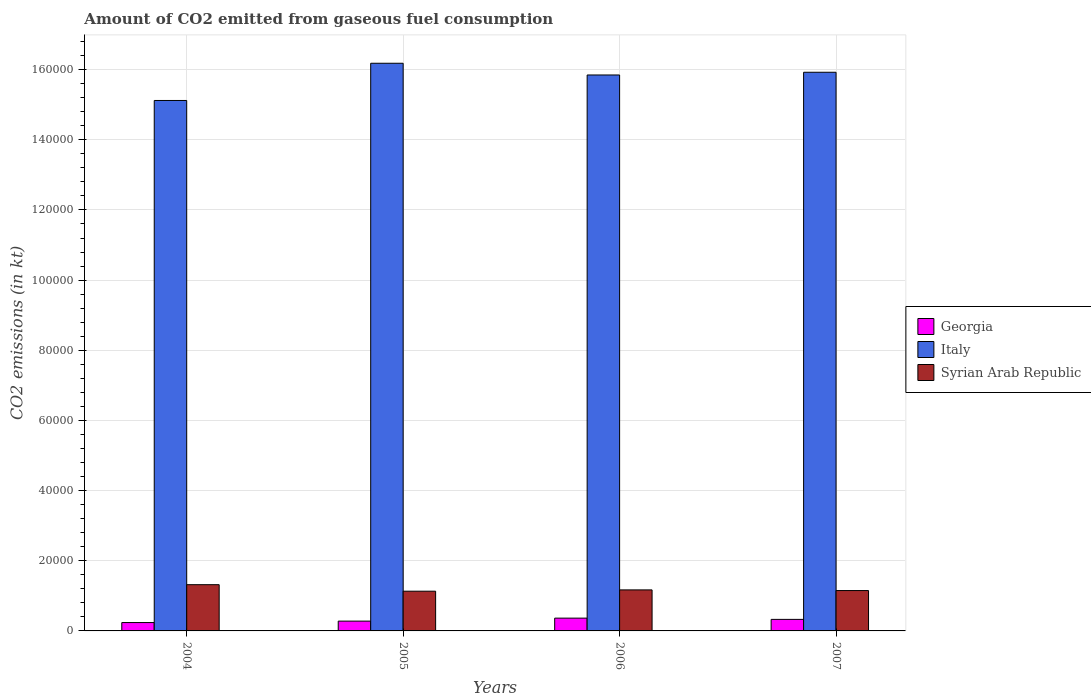How many groups of bars are there?
Make the answer very short. 4. Are the number of bars on each tick of the X-axis equal?
Provide a short and direct response. Yes. How many bars are there on the 2nd tick from the left?
Provide a short and direct response. 3. In how many cases, is the number of bars for a given year not equal to the number of legend labels?
Offer a very short reply. 0. What is the amount of CO2 emitted in Italy in 2006?
Provide a succinct answer. 1.58e+05. Across all years, what is the maximum amount of CO2 emitted in Italy?
Provide a short and direct response. 1.62e+05. Across all years, what is the minimum amount of CO2 emitted in Syrian Arab Republic?
Provide a succinct answer. 1.13e+04. In which year was the amount of CO2 emitted in Italy maximum?
Your answer should be very brief. 2005. What is the total amount of CO2 emitted in Italy in the graph?
Offer a terse response. 6.31e+05. What is the difference between the amount of CO2 emitted in Syrian Arab Republic in 2004 and that in 2006?
Make the answer very short. 1485.14. What is the difference between the amount of CO2 emitted in Syrian Arab Republic in 2007 and the amount of CO2 emitted in Italy in 2006?
Ensure brevity in your answer.  -1.47e+05. What is the average amount of CO2 emitted in Georgia per year?
Provide a succinct answer. 3028.03. In the year 2005, what is the difference between the amount of CO2 emitted in Georgia and amount of CO2 emitted in Syrian Arab Republic?
Provide a short and direct response. -8529.44. What is the ratio of the amount of CO2 emitted in Italy in 2004 to that in 2005?
Provide a short and direct response. 0.93. What is the difference between the highest and the second highest amount of CO2 emitted in Italy?
Your answer should be very brief. 2566.9. What is the difference between the highest and the lowest amount of CO2 emitted in Georgia?
Provide a short and direct response. 1261.45. In how many years, is the amount of CO2 emitted in Syrian Arab Republic greater than the average amount of CO2 emitted in Syrian Arab Republic taken over all years?
Provide a succinct answer. 1. Is the sum of the amount of CO2 emitted in Georgia in 2005 and 2006 greater than the maximum amount of CO2 emitted in Italy across all years?
Keep it short and to the point. No. Are all the bars in the graph horizontal?
Give a very brief answer. No. How many years are there in the graph?
Your answer should be compact. 4. What is the difference between two consecutive major ticks on the Y-axis?
Offer a very short reply. 2.00e+04. Does the graph contain any zero values?
Your answer should be compact. No. Does the graph contain grids?
Your answer should be very brief. Yes. Where does the legend appear in the graph?
Provide a short and direct response. Center right. What is the title of the graph?
Your answer should be very brief. Amount of CO2 emitted from gaseous fuel consumption. Does "American Samoa" appear as one of the legend labels in the graph?
Your answer should be compact. No. What is the label or title of the X-axis?
Provide a succinct answer. Years. What is the label or title of the Y-axis?
Offer a terse response. CO2 emissions (in kt). What is the CO2 emissions (in kt) in Georgia in 2004?
Provide a short and direct response. 2383.55. What is the CO2 emissions (in kt) in Italy in 2004?
Your answer should be very brief. 1.51e+05. What is the CO2 emissions (in kt) in Syrian Arab Republic in 2004?
Give a very brief answer. 1.32e+04. What is the CO2 emissions (in kt) of Georgia in 2005?
Provide a succinct answer. 2794.25. What is the CO2 emissions (in kt) of Italy in 2005?
Give a very brief answer. 1.62e+05. What is the CO2 emissions (in kt) in Syrian Arab Republic in 2005?
Keep it short and to the point. 1.13e+04. What is the CO2 emissions (in kt) in Georgia in 2006?
Offer a very short reply. 3645. What is the CO2 emissions (in kt) in Italy in 2006?
Provide a succinct answer. 1.58e+05. What is the CO2 emissions (in kt) of Syrian Arab Republic in 2006?
Give a very brief answer. 1.17e+04. What is the CO2 emissions (in kt) of Georgia in 2007?
Your answer should be compact. 3289.3. What is the CO2 emissions (in kt) of Italy in 2007?
Make the answer very short. 1.59e+05. What is the CO2 emissions (in kt) in Syrian Arab Republic in 2007?
Your answer should be compact. 1.15e+04. Across all years, what is the maximum CO2 emissions (in kt) of Georgia?
Ensure brevity in your answer.  3645. Across all years, what is the maximum CO2 emissions (in kt) of Italy?
Your answer should be very brief. 1.62e+05. Across all years, what is the maximum CO2 emissions (in kt) of Syrian Arab Republic?
Your answer should be very brief. 1.32e+04. Across all years, what is the minimum CO2 emissions (in kt) of Georgia?
Keep it short and to the point. 2383.55. Across all years, what is the minimum CO2 emissions (in kt) in Italy?
Make the answer very short. 1.51e+05. Across all years, what is the minimum CO2 emissions (in kt) in Syrian Arab Republic?
Your answer should be compact. 1.13e+04. What is the total CO2 emissions (in kt) of Georgia in the graph?
Offer a very short reply. 1.21e+04. What is the total CO2 emissions (in kt) of Italy in the graph?
Your answer should be very brief. 6.31e+05. What is the total CO2 emissions (in kt) of Syrian Arab Republic in the graph?
Offer a terse response. 4.77e+04. What is the difference between the CO2 emissions (in kt) of Georgia in 2004 and that in 2005?
Make the answer very short. -410.7. What is the difference between the CO2 emissions (in kt) of Italy in 2004 and that in 2005?
Make the answer very short. -1.06e+04. What is the difference between the CO2 emissions (in kt) of Syrian Arab Republic in 2004 and that in 2005?
Make the answer very short. 1855.5. What is the difference between the CO2 emissions (in kt) in Georgia in 2004 and that in 2006?
Your answer should be compact. -1261.45. What is the difference between the CO2 emissions (in kt) of Italy in 2004 and that in 2006?
Offer a terse response. -7267.99. What is the difference between the CO2 emissions (in kt) of Syrian Arab Republic in 2004 and that in 2006?
Keep it short and to the point. 1485.13. What is the difference between the CO2 emissions (in kt) in Georgia in 2004 and that in 2007?
Provide a succinct answer. -905.75. What is the difference between the CO2 emissions (in kt) of Italy in 2004 and that in 2007?
Your answer should be very brief. -8041.73. What is the difference between the CO2 emissions (in kt) of Syrian Arab Republic in 2004 and that in 2007?
Make the answer very short. 1672.15. What is the difference between the CO2 emissions (in kt) in Georgia in 2005 and that in 2006?
Your answer should be very brief. -850.74. What is the difference between the CO2 emissions (in kt) in Italy in 2005 and that in 2006?
Your response must be concise. 3340.64. What is the difference between the CO2 emissions (in kt) of Syrian Arab Republic in 2005 and that in 2006?
Ensure brevity in your answer.  -370.37. What is the difference between the CO2 emissions (in kt) in Georgia in 2005 and that in 2007?
Your response must be concise. -495.05. What is the difference between the CO2 emissions (in kt) of Italy in 2005 and that in 2007?
Your answer should be compact. 2566.9. What is the difference between the CO2 emissions (in kt) of Syrian Arab Republic in 2005 and that in 2007?
Offer a very short reply. -183.35. What is the difference between the CO2 emissions (in kt) of Georgia in 2006 and that in 2007?
Make the answer very short. 355.7. What is the difference between the CO2 emissions (in kt) of Italy in 2006 and that in 2007?
Make the answer very short. -773.74. What is the difference between the CO2 emissions (in kt) of Syrian Arab Republic in 2006 and that in 2007?
Ensure brevity in your answer.  187.02. What is the difference between the CO2 emissions (in kt) of Georgia in 2004 and the CO2 emissions (in kt) of Italy in 2005?
Your response must be concise. -1.59e+05. What is the difference between the CO2 emissions (in kt) of Georgia in 2004 and the CO2 emissions (in kt) of Syrian Arab Republic in 2005?
Make the answer very short. -8940.15. What is the difference between the CO2 emissions (in kt) in Italy in 2004 and the CO2 emissions (in kt) in Syrian Arab Republic in 2005?
Offer a very short reply. 1.40e+05. What is the difference between the CO2 emissions (in kt) of Georgia in 2004 and the CO2 emissions (in kt) of Italy in 2006?
Make the answer very short. -1.56e+05. What is the difference between the CO2 emissions (in kt) of Georgia in 2004 and the CO2 emissions (in kt) of Syrian Arab Republic in 2006?
Your answer should be very brief. -9310.51. What is the difference between the CO2 emissions (in kt) in Italy in 2004 and the CO2 emissions (in kt) in Syrian Arab Republic in 2006?
Offer a very short reply. 1.40e+05. What is the difference between the CO2 emissions (in kt) of Georgia in 2004 and the CO2 emissions (in kt) of Italy in 2007?
Ensure brevity in your answer.  -1.57e+05. What is the difference between the CO2 emissions (in kt) of Georgia in 2004 and the CO2 emissions (in kt) of Syrian Arab Republic in 2007?
Offer a very short reply. -9123.5. What is the difference between the CO2 emissions (in kt) in Italy in 2004 and the CO2 emissions (in kt) in Syrian Arab Republic in 2007?
Offer a very short reply. 1.40e+05. What is the difference between the CO2 emissions (in kt) in Georgia in 2005 and the CO2 emissions (in kt) in Italy in 2006?
Offer a terse response. -1.56e+05. What is the difference between the CO2 emissions (in kt) in Georgia in 2005 and the CO2 emissions (in kt) in Syrian Arab Republic in 2006?
Offer a very short reply. -8899.81. What is the difference between the CO2 emissions (in kt) of Italy in 2005 and the CO2 emissions (in kt) of Syrian Arab Republic in 2006?
Your answer should be compact. 1.50e+05. What is the difference between the CO2 emissions (in kt) in Georgia in 2005 and the CO2 emissions (in kt) in Italy in 2007?
Provide a succinct answer. -1.56e+05. What is the difference between the CO2 emissions (in kt) of Georgia in 2005 and the CO2 emissions (in kt) of Syrian Arab Republic in 2007?
Your answer should be compact. -8712.79. What is the difference between the CO2 emissions (in kt) of Italy in 2005 and the CO2 emissions (in kt) of Syrian Arab Republic in 2007?
Keep it short and to the point. 1.50e+05. What is the difference between the CO2 emissions (in kt) in Georgia in 2006 and the CO2 emissions (in kt) in Italy in 2007?
Give a very brief answer. -1.56e+05. What is the difference between the CO2 emissions (in kt) in Georgia in 2006 and the CO2 emissions (in kt) in Syrian Arab Republic in 2007?
Give a very brief answer. -7862.05. What is the difference between the CO2 emissions (in kt) of Italy in 2006 and the CO2 emissions (in kt) of Syrian Arab Republic in 2007?
Ensure brevity in your answer.  1.47e+05. What is the average CO2 emissions (in kt) of Georgia per year?
Your response must be concise. 3028.03. What is the average CO2 emissions (in kt) of Italy per year?
Your response must be concise. 1.58e+05. What is the average CO2 emissions (in kt) of Syrian Arab Republic per year?
Your answer should be very brief. 1.19e+04. In the year 2004, what is the difference between the CO2 emissions (in kt) in Georgia and CO2 emissions (in kt) in Italy?
Your response must be concise. -1.49e+05. In the year 2004, what is the difference between the CO2 emissions (in kt) of Georgia and CO2 emissions (in kt) of Syrian Arab Republic?
Make the answer very short. -1.08e+04. In the year 2004, what is the difference between the CO2 emissions (in kt) of Italy and CO2 emissions (in kt) of Syrian Arab Republic?
Ensure brevity in your answer.  1.38e+05. In the year 2005, what is the difference between the CO2 emissions (in kt) of Georgia and CO2 emissions (in kt) of Italy?
Offer a terse response. -1.59e+05. In the year 2005, what is the difference between the CO2 emissions (in kt) in Georgia and CO2 emissions (in kt) in Syrian Arab Republic?
Offer a very short reply. -8529.44. In the year 2005, what is the difference between the CO2 emissions (in kt) of Italy and CO2 emissions (in kt) of Syrian Arab Republic?
Give a very brief answer. 1.50e+05. In the year 2006, what is the difference between the CO2 emissions (in kt) of Georgia and CO2 emissions (in kt) of Italy?
Your answer should be very brief. -1.55e+05. In the year 2006, what is the difference between the CO2 emissions (in kt) of Georgia and CO2 emissions (in kt) of Syrian Arab Republic?
Give a very brief answer. -8049.06. In the year 2006, what is the difference between the CO2 emissions (in kt) of Italy and CO2 emissions (in kt) of Syrian Arab Republic?
Your response must be concise. 1.47e+05. In the year 2007, what is the difference between the CO2 emissions (in kt) in Georgia and CO2 emissions (in kt) in Italy?
Give a very brief answer. -1.56e+05. In the year 2007, what is the difference between the CO2 emissions (in kt) in Georgia and CO2 emissions (in kt) in Syrian Arab Republic?
Offer a very short reply. -8217.75. In the year 2007, what is the difference between the CO2 emissions (in kt) in Italy and CO2 emissions (in kt) in Syrian Arab Republic?
Make the answer very short. 1.48e+05. What is the ratio of the CO2 emissions (in kt) in Georgia in 2004 to that in 2005?
Your response must be concise. 0.85. What is the ratio of the CO2 emissions (in kt) in Italy in 2004 to that in 2005?
Your answer should be compact. 0.93. What is the ratio of the CO2 emissions (in kt) in Syrian Arab Republic in 2004 to that in 2005?
Offer a terse response. 1.16. What is the ratio of the CO2 emissions (in kt) of Georgia in 2004 to that in 2006?
Provide a succinct answer. 0.65. What is the ratio of the CO2 emissions (in kt) of Italy in 2004 to that in 2006?
Offer a very short reply. 0.95. What is the ratio of the CO2 emissions (in kt) of Syrian Arab Republic in 2004 to that in 2006?
Your answer should be compact. 1.13. What is the ratio of the CO2 emissions (in kt) in Georgia in 2004 to that in 2007?
Your answer should be compact. 0.72. What is the ratio of the CO2 emissions (in kt) of Italy in 2004 to that in 2007?
Your answer should be very brief. 0.95. What is the ratio of the CO2 emissions (in kt) of Syrian Arab Republic in 2004 to that in 2007?
Your answer should be compact. 1.15. What is the ratio of the CO2 emissions (in kt) in Georgia in 2005 to that in 2006?
Keep it short and to the point. 0.77. What is the ratio of the CO2 emissions (in kt) in Italy in 2005 to that in 2006?
Your answer should be compact. 1.02. What is the ratio of the CO2 emissions (in kt) in Syrian Arab Republic in 2005 to that in 2006?
Your response must be concise. 0.97. What is the ratio of the CO2 emissions (in kt) in Georgia in 2005 to that in 2007?
Offer a very short reply. 0.85. What is the ratio of the CO2 emissions (in kt) in Italy in 2005 to that in 2007?
Ensure brevity in your answer.  1.02. What is the ratio of the CO2 emissions (in kt) in Syrian Arab Republic in 2005 to that in 2007?
Your answer should be compact. 0.98. What is the ratio of the CO2 emissions (in kt) in Georgia in 2006 to that in 2007?
Your answer should be compact. 1.11. What is the ratio of the CO2 emissions (in kt) in Italy in 2006 to that in 2007?
Ensure brevity in your answer.  1. What is the ratio of the CO2 emissions (in kt) of Syrian Arab Republic in 2006 to that in 2007?
Keep it short and to the point. 1.02. What is the difference between the highest and the second highest CO2 emissions (in kt) in Georgia?
Offer a terse response. 355.7. What is the difference between the highest and the second highest CO2 emissions (in kt) of Italy?
Provide a succinct answer. 2566.9. What is the difference between the highest and the second highest CO2 emissions (in kt) of Syrian Arab Republic?
Keep it short and to the point. 1485.13. What is the difference between the highest and the lowest CO2 emissions (in kt) in Georgia?
Give a very brief answer. 1261.45. What is the difference between the highest and the lowest CO2 emissions (in kt) of Italy?
Give a very brief answer. 1.06e+04. What is the difference between the highest and the lowest CO2 emissions (in kt) in Syrian Arab Republic?
Offer a very short reply. 1855.5. 